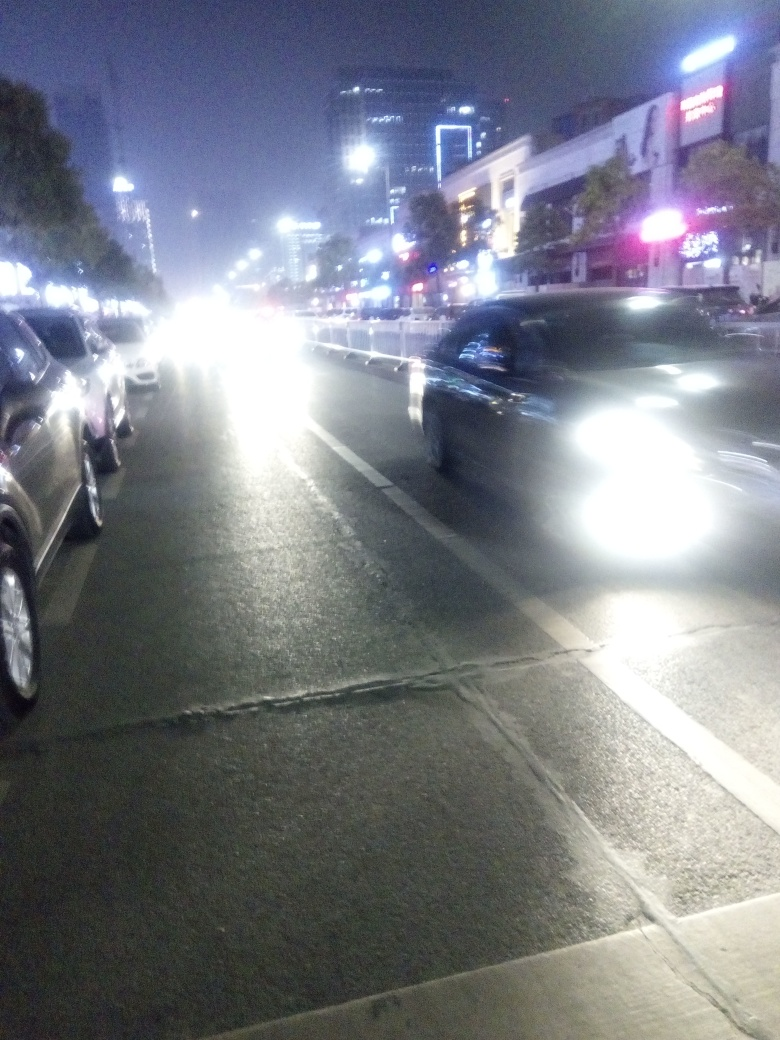What does the presence of vehicles at night indicate about the lifestyle in this area? The number of vehicles present at night suggests that this area is bustling, with people likely traveling for work, social engagements, or late-night activities. It indicates a city that has an active evening lifestyle, with transportation infrastructure that supports night-time commuting. 